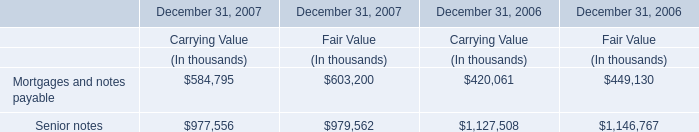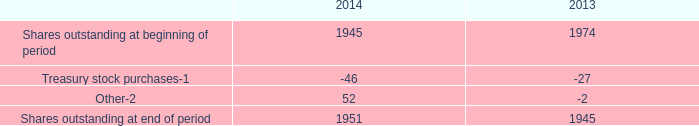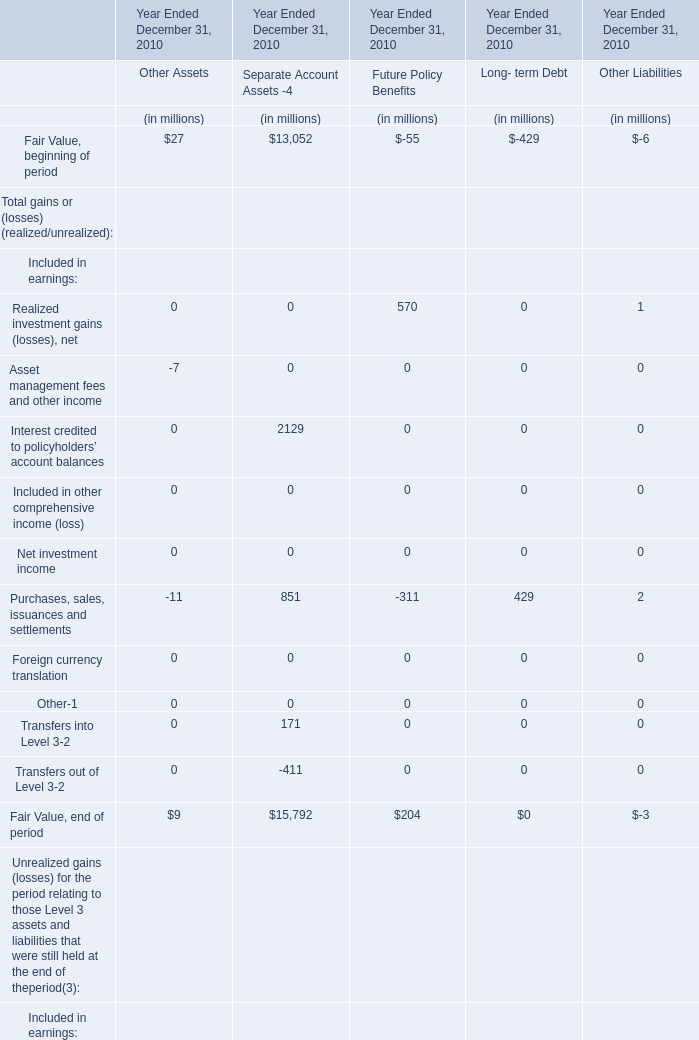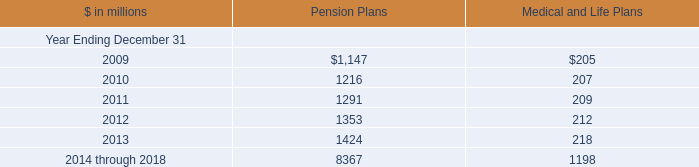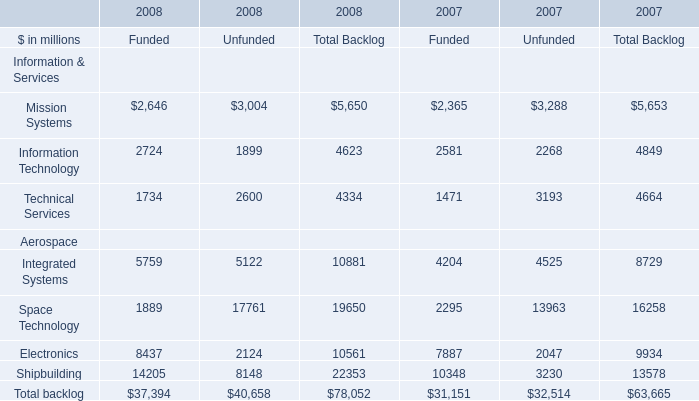What is the total amount of Shares outstanding at end of period of 2013, and Shipbuilding Aerospace of 2007 Unfunded ? 
Computations: (1945.0 + 3230.0)
Answer: 5175.0. 